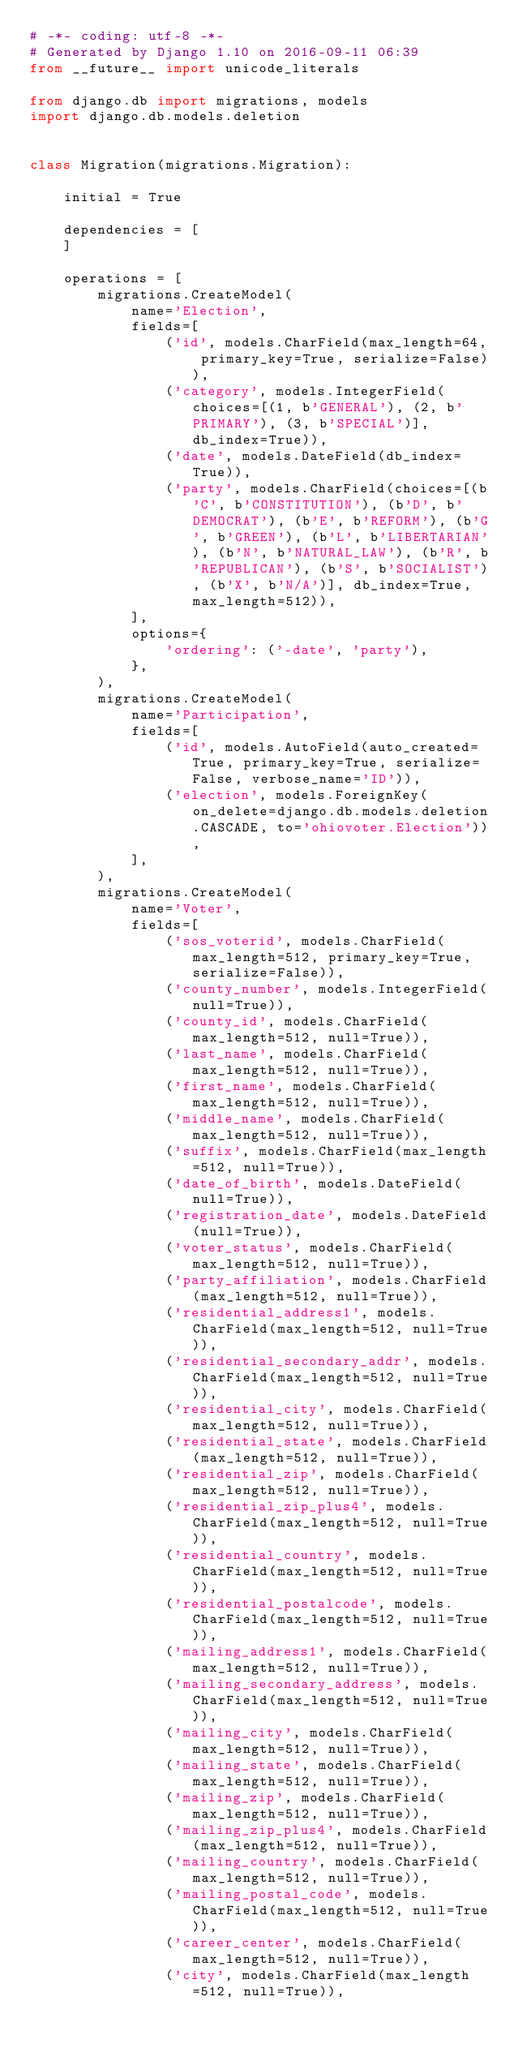<code> <loc_0><loc_0><loc_500><loc_500><_Python_># -*- coding: utf-8 -*-
# Generated by Django 1.10 on 2016-09-11 06:39
from __future__ import unicode_literals

from django.db import migrations, models
import django.db.models.deletion


class Migration(migrations.Migration):

    initial = True

    dependencies = [
    ]

    operations = [
        migrations.CreateModel(
            name='Election',
            fields=[
                ('id', models.CharField(max_length=64, primary_key=True, serialize=False)),
                ('category', models.IntegerField(choices=[(1, b'GENERAL'), (2, b'PRIMARY'), (3, b'SPECIAL')], db_index=True)),
                ('date', models.DateField(db_index=True)),
                ('party', models.CharField(choices=[(b'C', b'CONSTITUTION'), (b'D', b'DEMOCRAT'), (b'E', b'REFORM'), (b'G', b'GREEN'), (b'L', b'LIBERTARIAN'), (b'N', b'NATURAL_LAW'), (b'R', b'REPUBLICAN'), (b'S', b'SOCIALIST'), (b'X', b'N/A')], db_index=True, max_length=512)),
            ],
            options={
                'ordering': ('-date', 'party'),
            },
        ),
        migrations.CreateModel(
            name='Participation',
            fields=[
                ('id', models.AutoField(auto_created=True, primary_key=True, serialize=False, verbose_name='ID')),
                ('election', models.ForeignKey(on_delete=django.db.models.deletion.CASCADE, to='ohiovoter.Election')),
            ],
        ),
        migrations.CreateModel(
            name='Voter',
            fields=[
                ('sos_voterid', models.CharField(max_length=512, primary_key=True, serialize=False)),
                ('county_number', models.IntegerField(null=True)),
                ('county_id', models.CharField(max_length=512, null=True)),
                ('last_name', models.CharField(max_length=512, null=True)),
                ('first_name', models.CharField(max_length=512, null=True)),
                ('middle_name', models.CharField(max_length=512, null=True)),
                ('suffix', models.CharField(max_length=512, null=True)),
                ('date_of_birth', models.DateField(null=True)),
                ('registration_date', models.DateField(null=True)),
                ('voter_status', models.CharField(max_length=512, null=True)),
                ('party_affiliation', models.CharField(max_length=512, null=True)),
                ('residential_address1', models.CharField(max_length=512, null=True)),
                ('residential_secondary_addr', models.CharField(max_length=512, null=True)),
                ('residential_city', models.CharField(max_length=512, null=True)),
                ('residential_state', models.CharField(max_length=512, null=True)),
                ('residential_zip', models.CharField(max_length=512, null=True)),
                ('residential_zip_plus4', models.CharField(max_length=512, null=True)),
                ('residential_country', models.CharField(max_length=512, null=True)),
                ('residential_postalcode', models.CharField(max_length=512, null=True)),
                ('mailing_address1', models.CharField(max_length=512, null=True)),
                ('mailing_secondary_address', models.CharField(max_length=512, null=True)),
                ('mailing_city', models.CharField(max_length=512, null=True)),
                ('mailing_state', models.CharField(max_length=512, null=True)),
                ('mailing_zip', models.CharField(max_length=512, null=True)),
                ('mailing_zip_plus4', models.CharField(max_length=512, null=True)),
                ('mailing_country', models.CharField(max_length=512, null=True)),
                ('mailing_postal_code', models.CharField(max_length=512, null=True)),
                ('career_center', models.CharField(max_length=512, null=True)),
                ('city', models.CharField(max_length=512, null=True)),</code> 